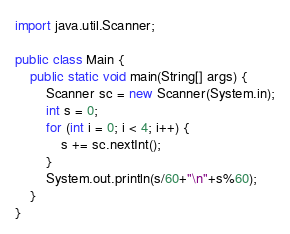<code> <loc_0><loc_0><loc_500><loc_500><_Java_>import java.util.Scanner;

public class Main {
    public static void main(String[] args) {
        Scanner sc = new Scanner(System.in);
        int s = 0;
        for (int i = 0; i < 4; i++) {
            s += sc.nextInt();
        }
        System.out.println(s/60+"\n"+s%60);
    }
}
</code> 